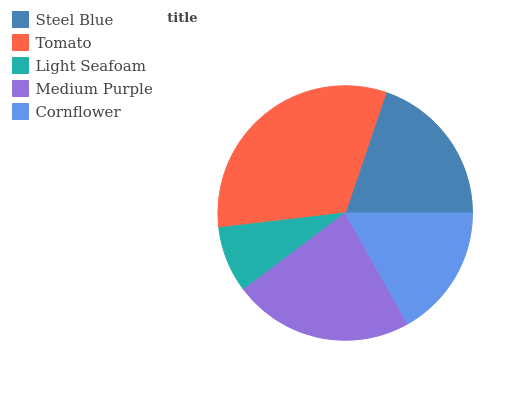Is Light Seafoam the minimum?
Answer yes or no. Yes. Is Tomato the maximum?
Answer yes or no. Yes. Is Tomato the minimum?
Answer yes or no. No. Is Light Seafoam the maximum?
Answer yes or no. No. Is Tomato greater than Light Seafoam?
Answer yes or no. Yes. Is Light Seafoam less than Tomato?
Answer yes or no. Yes. Is Light Seafoam greater than Tomato?
Answer yes or no. No. Is Tomato less than Light Seafoam?
Answer yes or no. No. Is Steel Blue the high median?
Answer yes or no. Yes. Is Steel Blue the low median?
Answer yes or no. Yes. Is Light Seafoam the high median?
Answer yes or no. No. Is Tomato the low median?
Answer yes or no. No. 